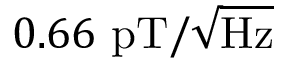Convert formula to latex. <formula><loc_0><loc_0><loc_500><loc_500>0 . 6 6 p T / \sqrt { \mathrm } { H z }</formula> 